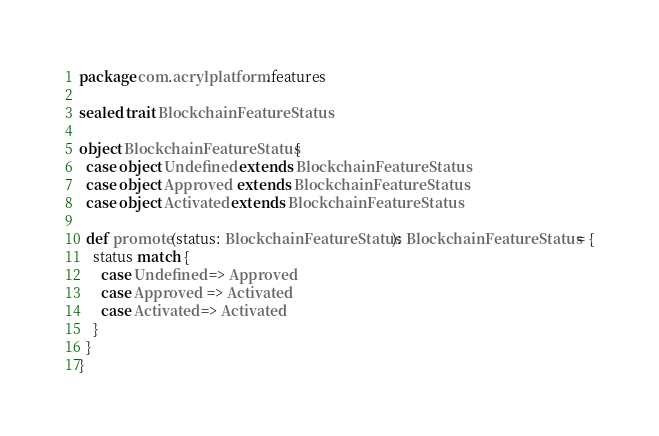Convert code to text. <code><loc_0><loc_0><loc_500><loc_500><_Scala_>package com.acrylplatform.features

sealed trait BlockchainFeatureStatus

object BlockchainFeatureStatus {
  case object Undefined extends BlockchainFeatureStatus
  case object Approved  extends BlockchainFeatureStatus
  case object Activated extends BlockchainFeatureStatus

  def promote(status: BlockchainFeatureStatus): BlockchainFeatureStatus = {
    status match {
      case Undefined => Approved
      case Approved  => Activated
      case Activated => Activated
    }
  }
}
</code> 